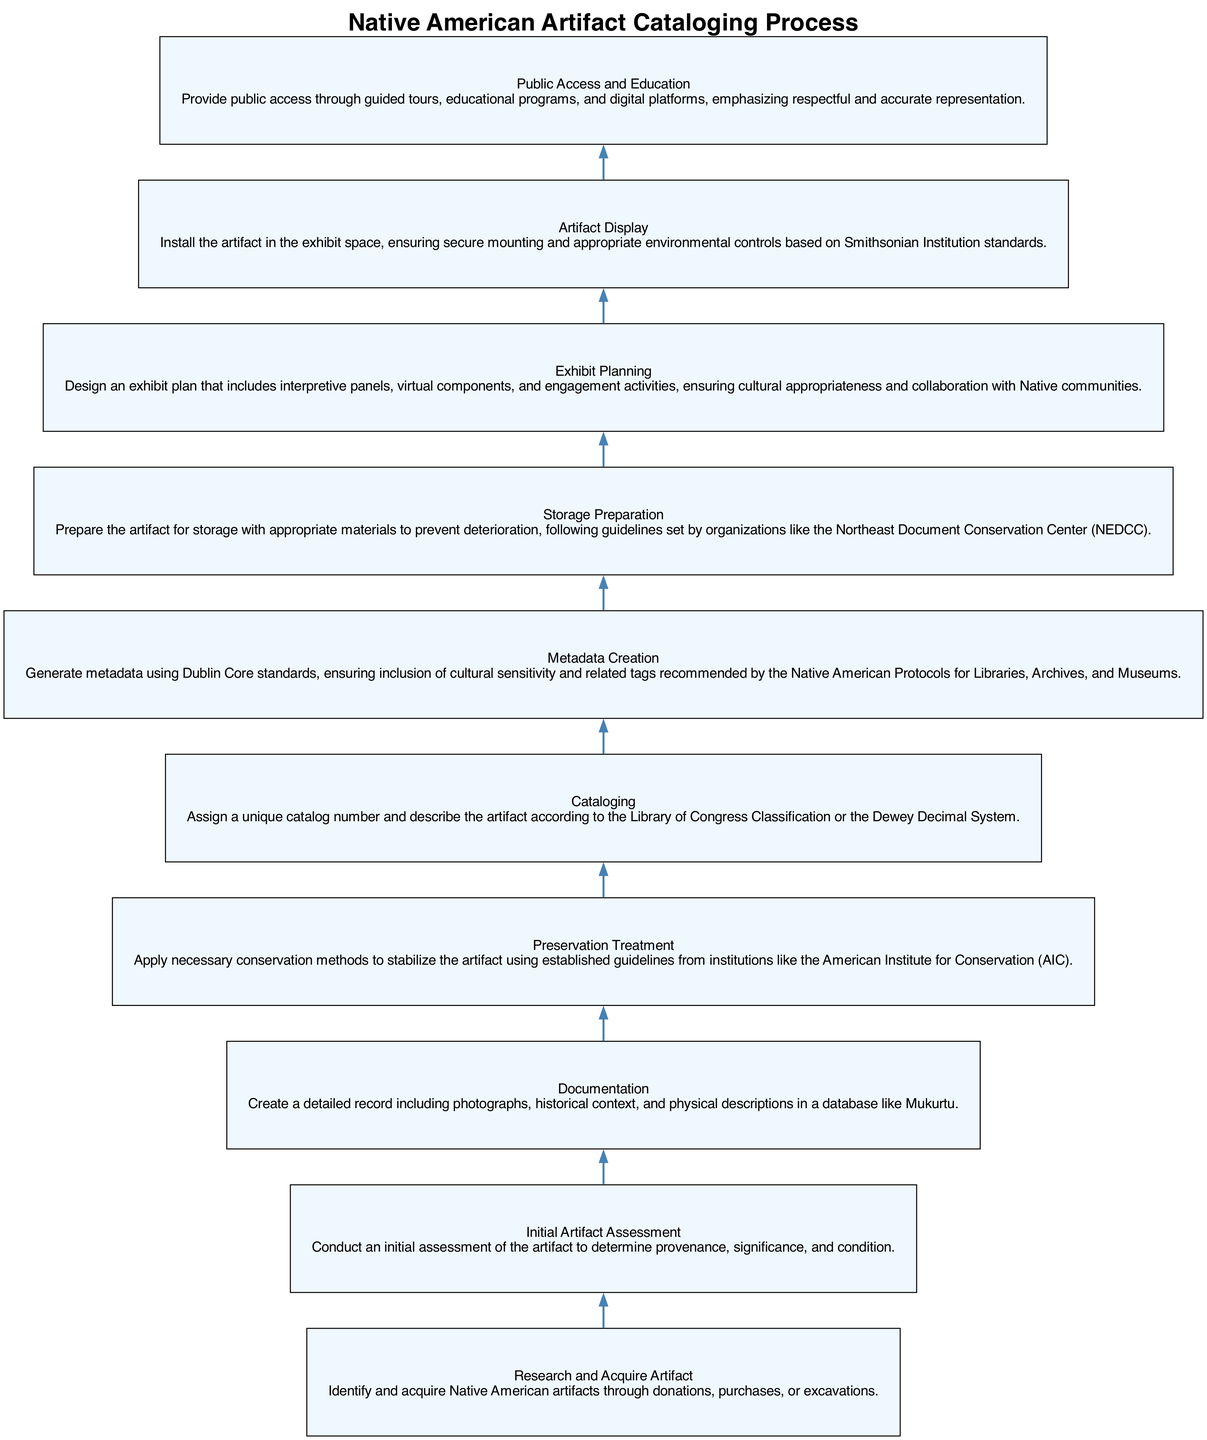What is the first step in the cataloging process? The first step is to "Research and Acquire Artifact". This can be found at the bottom of the diagram as the initial action required before any other steps can be considered.
Answer: Research and Acquire Artifact How many total steps are there in the process? By counting each distinct node in the diagram, we find that there are ten steps listed sequentially from acquisition to display.
Answer: 10 What step comes directly after "Initial Artifact Assessment"? The step that directly follows "Initial Artifact Assessment" is "Documentation", as indicated by the edge connecting these two nodes in the flow.
Answer: Documentation What is the focus of the "Metadata Creation" step? The "Metadata Creation" step emphasizes generating metadata, specifically mentioning the use of Dublin Core standards and cultural sensitivity. This step highlights the informative aspect of the artifact's records.
Answer: Generate metadata Which step involves collaboration with Native communities? The step titled "Exhibit Planning" explicitly mentions ensuring cultural appropriateness and collaboration with Native communities, indicating that this is where such interaction is considered.
Answer: Exhibit Planning What is a consequence of the "Preservation Treatment" step? A consequence of the "Preservation Treatment" is the stabilization of the artifact using conservation methods, which is crucial for maintaining its condition for future display.
Answer: Stabilize the artifact What is the last action taken in the outlined process? The final action is "Public Access and Education", which serves as the culmination of the entire cataloging process, offering access and educational resources to the public.
Answer: Public Access and Education What labeling system is used during the "Cataloging" step? The "Cataloging" step mentions the assignment of unique catalog numbers and indicates the use of either the Library of Congress Classification or the Dewey Decimal System for organization.
Answer: Library of Congress Classification or Dewey Decimal System Which step happens just before "Artifact Display"? The step that occurs just prior to "Artifact Display" is "Exhibit Planning", as the plan must be created and finalized before the actual display can take place in the exhibit space.
Answer: Exhibit Planning What standards are referenced in the "Storage Preparation" step? The "Storage Preparation" step refers to guidelines set by the Northeast Document Conservation Center (NEDCC) for preparing artifacts for storage. This ensures that the artifacts are well-preserved while not in display.
Answer: Northeast Document Conservation Center 